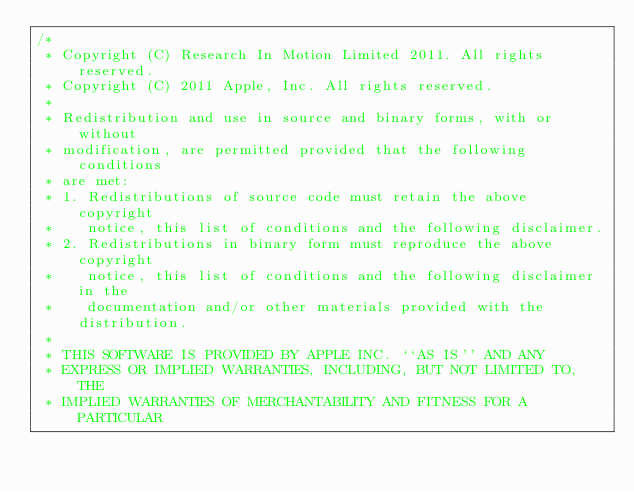<code> <loc_0><loc_0><loc_500><loc_500><_C_>/*
 * Copyright (C) Research In Motion Limited 2011. All rights reserved.
 * Copyright (C) 2011 Apple, Inc. All rights reserved.
 *
 * Redistribution and use in source and binary forms, with or without
 * modification, are permitted provided that the following conditions
 * are met:
 * 1. Redistributions of source code must retain the above copyright
 *    notice, this list of conditions and the following disclaimer.
 * 2. Redistributions in binary form must reproduce the above copyright
 *    notice, this list of conditions and the following disclaimer in the
 *    documentation and/or other materials provided with the distribution.
 *
 * THIS SOFTWARE IS PROVIDED BY APPLE INC. ``AS IS'' AND ANY
 * EXPRESS OR IMPLIED WARRANTIES, INCLUDING, BUT NOT LIMITED TO, THE
 * IMPLIED WARRANTIES OF MERCHANTABILITY AND FITNESS FOR A PARTICULAR</code> 